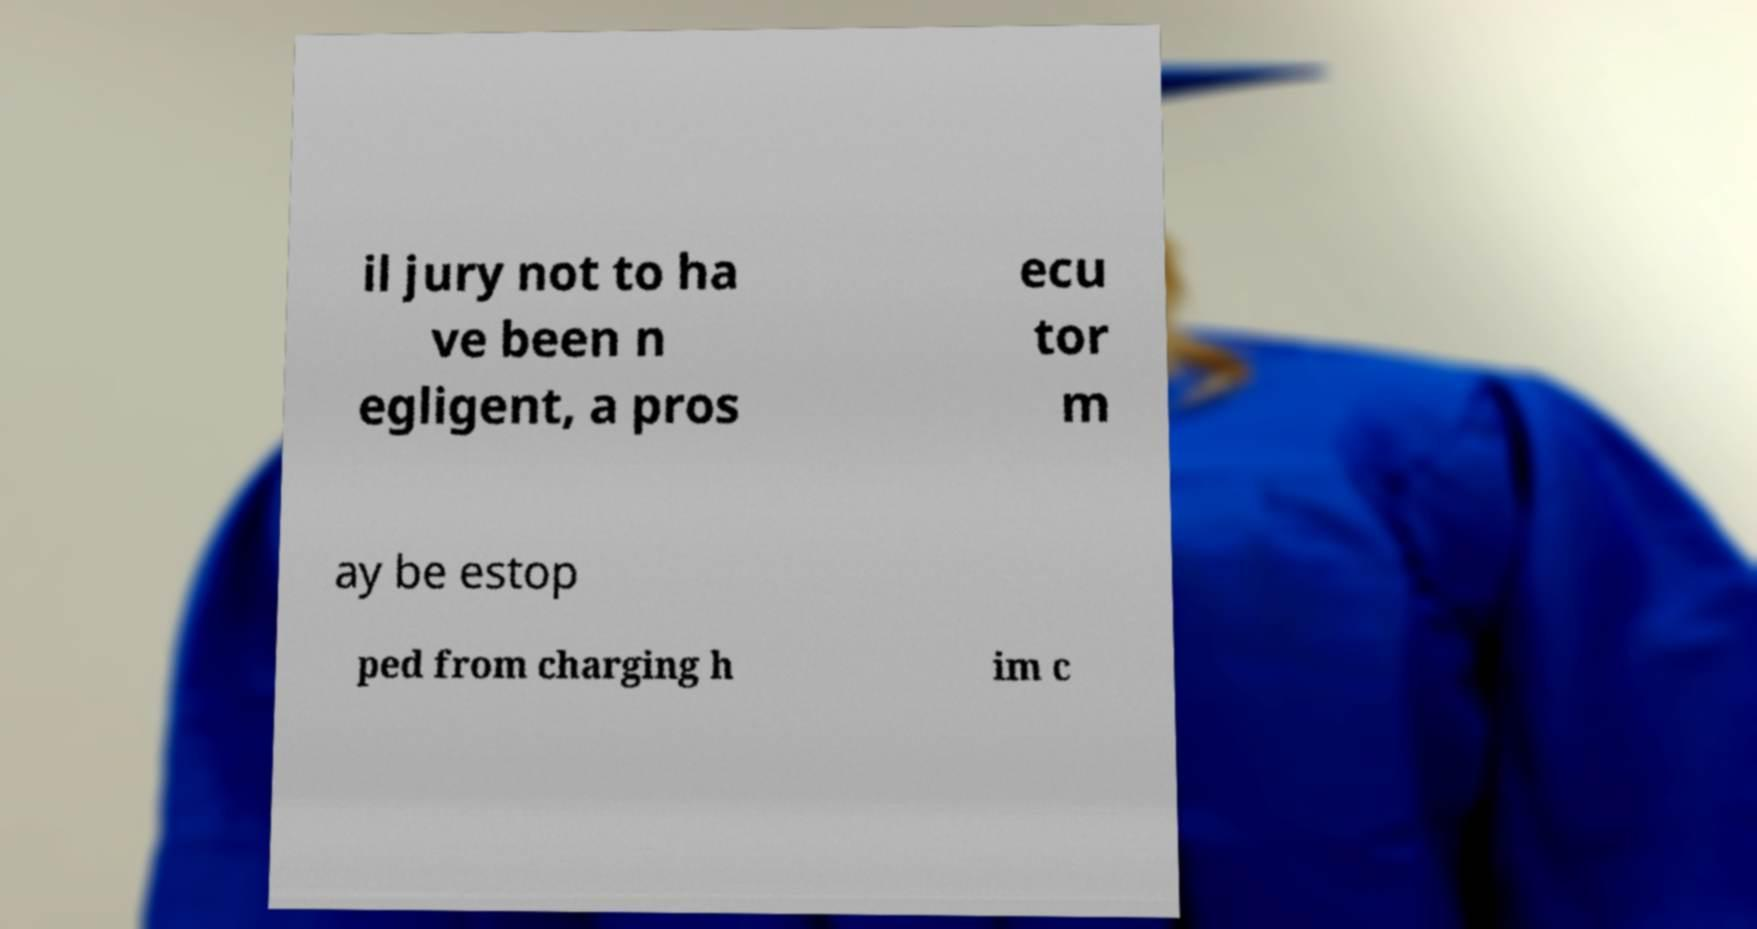Could you assist in decoding the text presented in this image and type it out clearly? il jury not to ha ve been n egligent, a pros ecu tor m ay be estop ped from charging h im c 